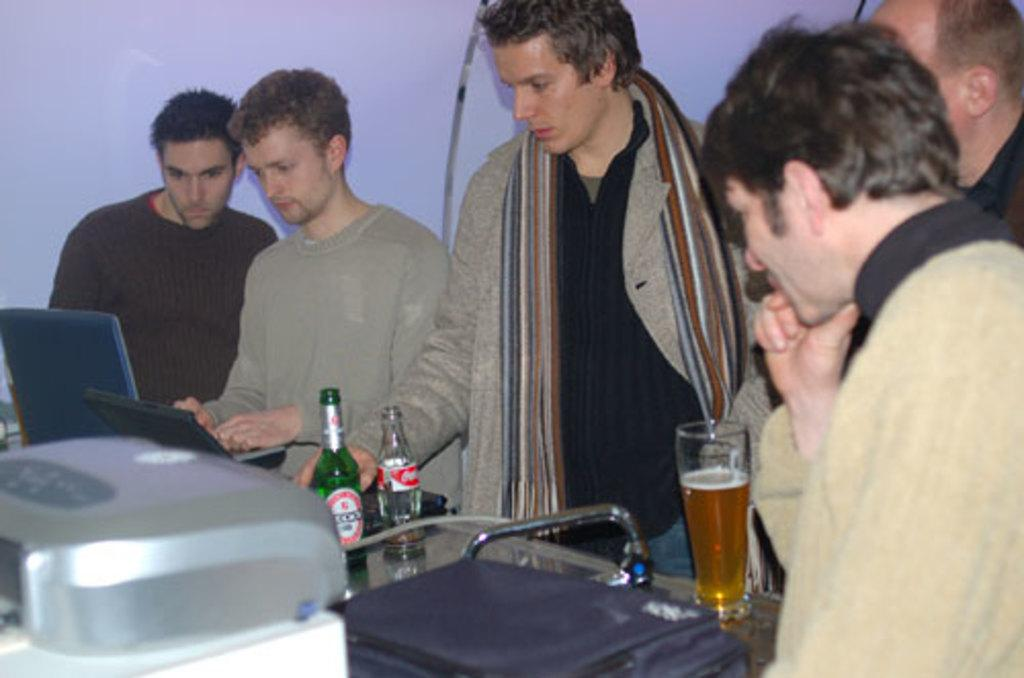How many people are present in the image? There are five people standing in the image. What objects can be seen on the table in the image? There is a bottle, a glass, and a laptop on the table. What type of ice can be seen melting on the laptop in the image? There is no ice present in the image, and the laptop is not associated with any melting ice. 